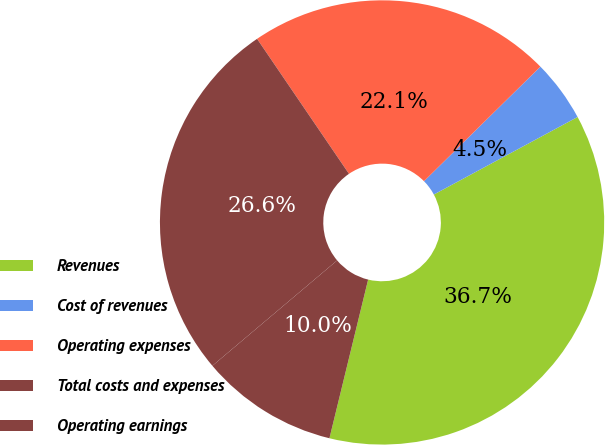<chart> <loc_0><loc_0><loc_500><loc_500><pie_chart><fcel>Revenues<fcel>Cost of revenues<fcel>Operating expenses<fcel>Total costs and expenses<fcel>Operating earnings<nl><fcel>36.68%<fcel>4.5%<fcel>22.14%<fcel>26.65%<fcel>10.03%<nl></chart> 